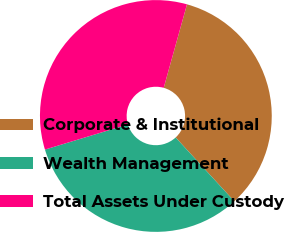<chart> <loc_0><loc_0><loc_500><loc_500><pie_chart><fcel>Corporate & Institutional<fcel>Wealth Management<fcel>Total Assets Under Custody<nl><fcel>33.84%<fcel>32.15%<fcel>34.01%<nl></chart> 